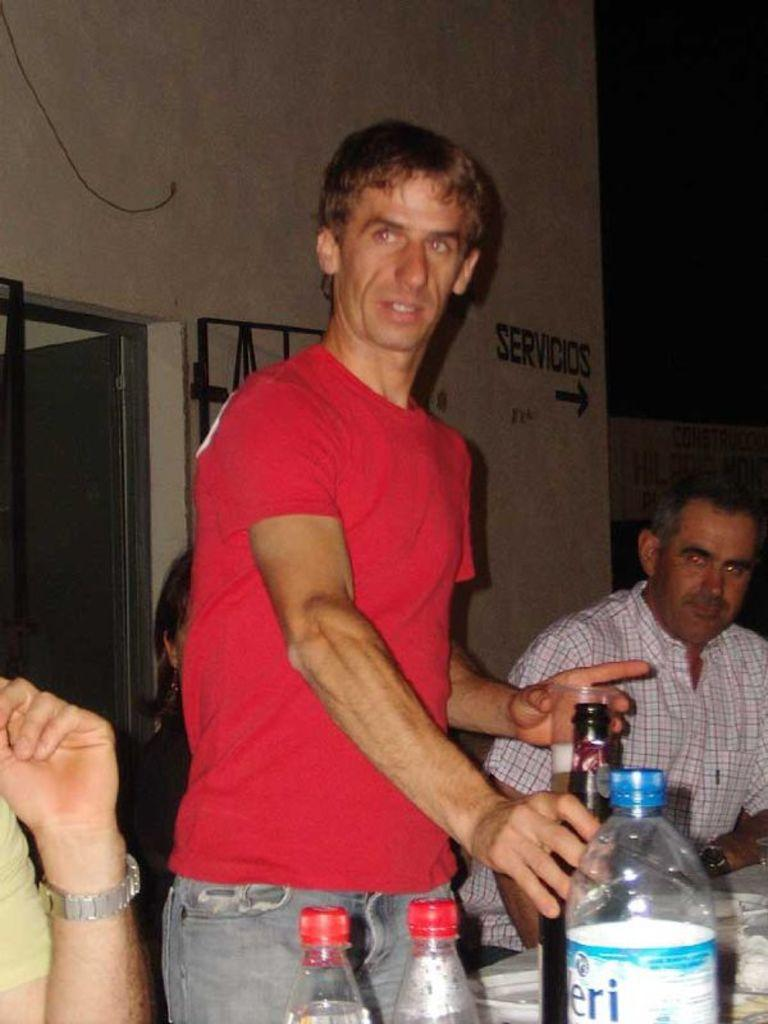What is the main subject of the image? There is a man standing in the image. Are there any other people in the image besides the man? Yes, there are other people in the image. What can be seen on the table in the image? There is a wine bottle and water bottles on the table. What is the purpose of the table in the image? The table is likely used for holding the wine bottle and water bottles. What type of servant is attending to the man in the image? There is no servant present in the image. Can you tell me how many fangs the man has in the image? There are no fangs visible in the image, as it features people and objects in a normal setting. 